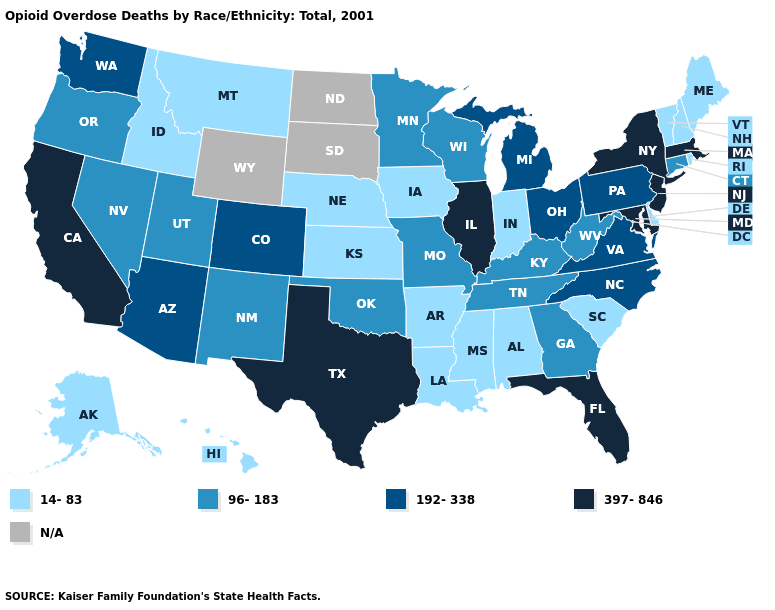What is the lowest value in the South?
Give a very brief answer. 14-83. What is the value of South Carolina?
Quick response, please. 14-83. What is the value of Connecticut?
Be succinct. 96-183. What is the value of Rhode Island?
Concise answer only. 14-83. Name the states that have a value in the range 96-183?
Keep it brief. Connecticut, Georgia, Kentucky, Minnesota, Missouri, Nevada, New Mexico, Oklahoma, Oregon, Tennessee, Utah, West Virginia, Wisconsin. Name the states that have a value in the range N/A?
Be succinct. North Dakota, South Dakota, Wyoming. What is the value of Massachusetts?
Keep it brief. 397-846. What is the highest value in the West ?
Keep it brief. 397-846. What is the value of South Carolina?
Quick response, please. 14-83. Name the states that have a value in the range 397-846?
Write a very short answer. California, Florida, Illinois, Maryland, Massachusetts, New Jersey, New York, Texas. What is the value of North Carolina?
Quick response, please. 192-338. What is the lowest value in the MidWest?
Keep it brief. 14-83. 